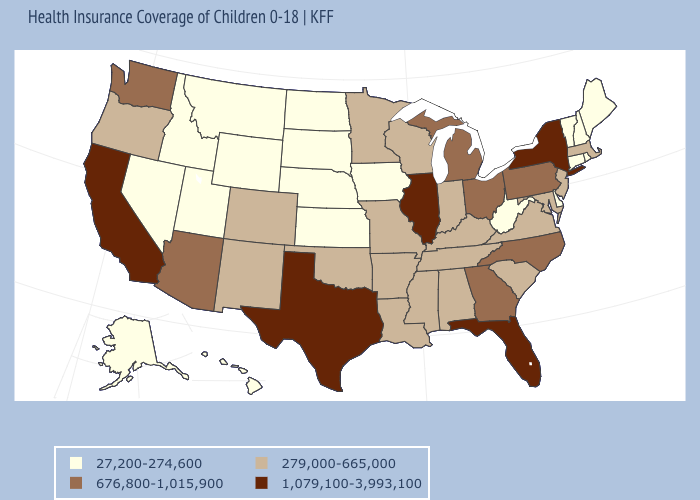Does New Mexico have the highest value in the USA?
Keep it brief. No. Does Pennsylvania have a lower value than California?
Short answer required. Yes. What is the lowest value in the USA?
Quick response, please. 27,200-274,600. Among the states that border Idaho , which have the lowest value?
Keep it brief. Montana, Nevada, Utah, Wyoming. Name the states that have a value in the range 27,200-274,600?
Answer briefly. Alaska, Connecticut, Delaware, Hawaii, Idaho, Iowa, Kansas, Maine, Montana, Nebraska, Nevada, New Hampshire, North Dakota, Rhode Island, South Dakota, Utah, Vermont, West Virginia, Wyoming. Which states have the highest value in the USA?
Concise answer only. California, Florida, Illinois, New York, Texas. Name the states that have a value in the range 1,079,100-3,993,100?
Quick response, please. California, Florida, Illinois, New York, Texas. What is the lowest value in the MidWest?
Write a very short answer. 27,200-274,600. What is the lowest value in states that border Maryland?
Be succinct. 27,200-274,600. Name the states that have a value in the range 27,200-274,600?
Short answer required. Alaska, Connecticut, Delaware, Hawaii, Idaho, Iowa, Kansas, Maine, Montana, Nebraska, Nevada, New Hampshire, North Dakota, Rhode Island, South Dakota, Utah, Vermont, West Virginia, Wyoming. What is the value of North Carolina?
Be succinct. 676,800-1,015,900. What is the highest value in the USA?
Give a very brief answer. 1,079,100-3,993,100. Does the first symbol in the legend represent the smallest category?
Short answer required. Yes. Among the states that border Illinois , does Iowa have the lowest value?
Be succinct. Yes. Does Delaware have the highest value in the South?
Quick response, please. No. 